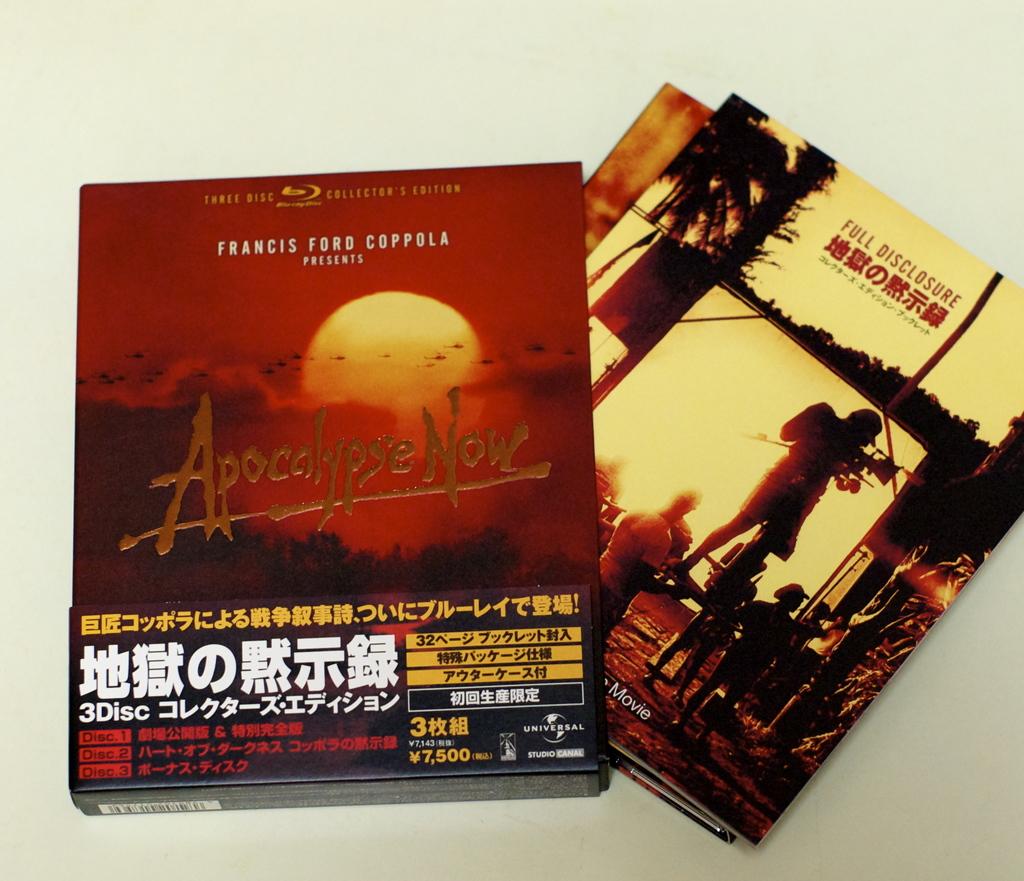Are all of the movies in the frame gory?
Your answer should be very brief. Yes. Who wrote the book on top?
Your answer should be compact. Francis ford coppola. 